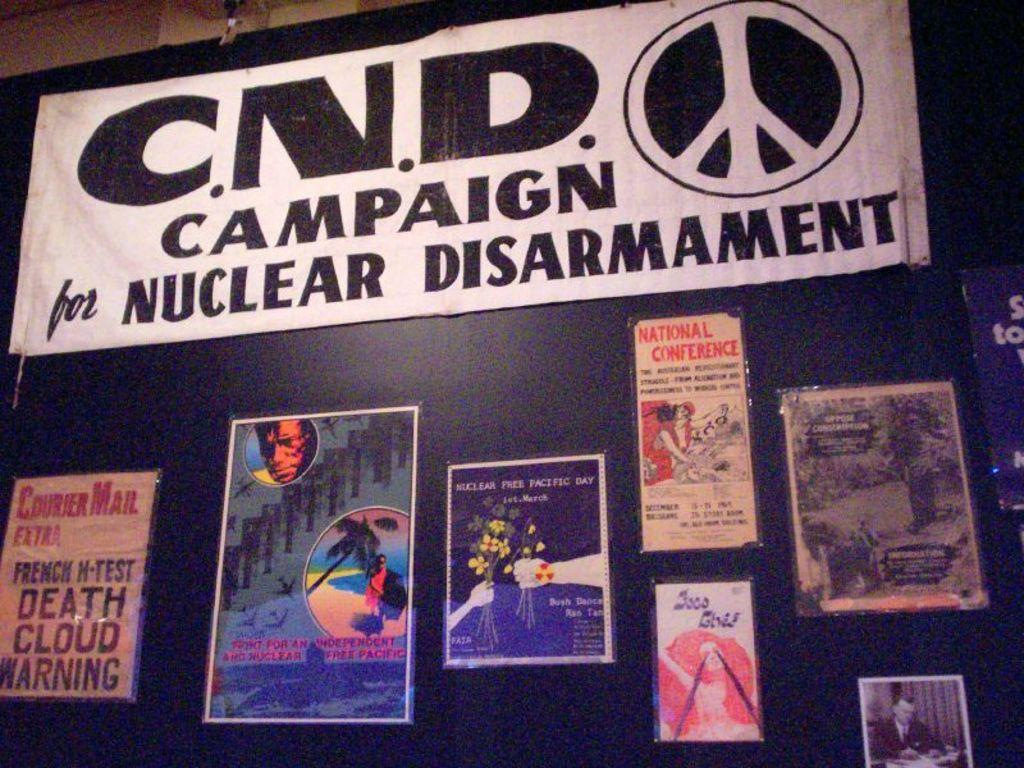What type of visuals are present on the walls in the image? There are posters in the image. What can be seen on the blackboard in the image? There is a notice pasted on a blackboard in the image. What color is the thread used to hang the posters in the image? There is no thread visible in the image, as the posters are likely attached to the wall using other methods, such as adhesive or push pins. 